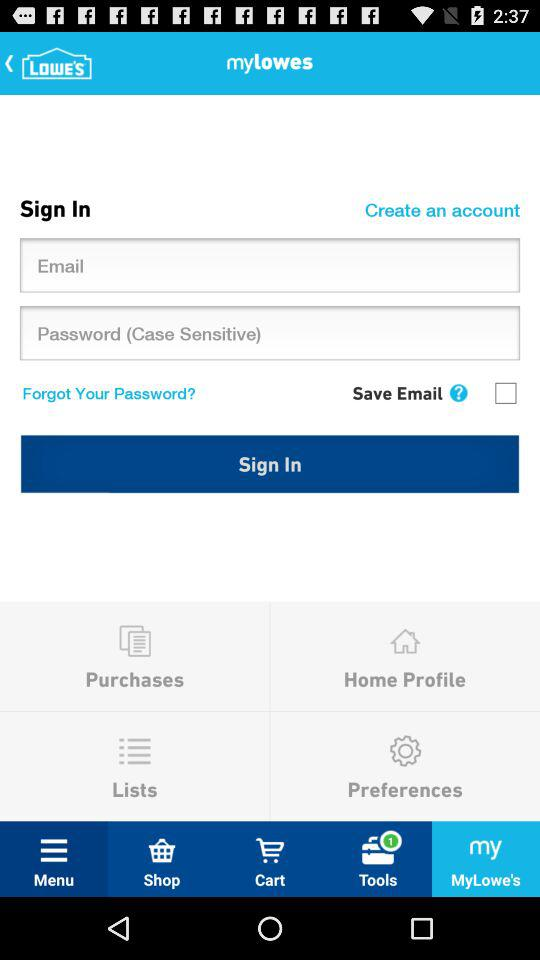What is the status of "Save Email"? The status of "Save Email" is "off". 